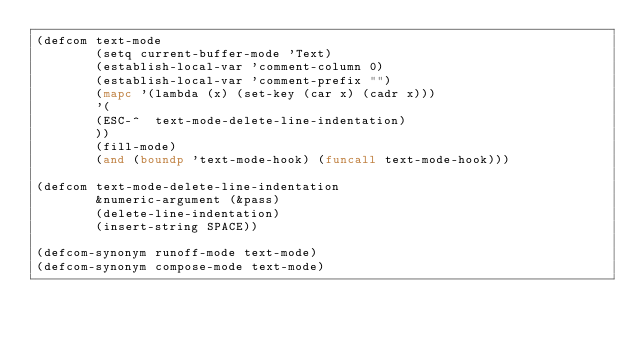<code> <loc_0><loc_0><loc_500><loc_500><_Lisp_>(defcom text-mode
        (setq current-buffer-mode 'Text)
        (establish-local-var 'comment-column 0)
        (establish-local-var 'comment-prefix "")
        (mapc '(lambda (x) (set-key (car x) (cadr x)))
	    '(
	    (ESC-^	text-mode-delete-line-indentation)
	    ))
        (fill-mode)
        (and (boundp 'text-mode-hook) (funcall text-mode-hook)))

(defcom text-mode-delete-line-indentation
        &numeric-argument (&pass)
        (delete-line-indentation)
        (insert-string SPACE))

(defcom-synonym runoff-mode text-mode)
(defcom-synonym compose-mode text-mode)

</code> 